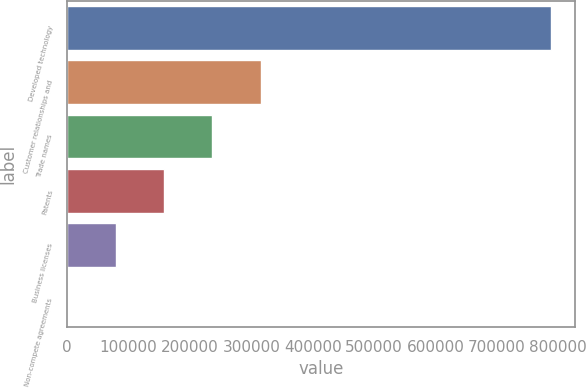Convert chart. <chart><loc_0><loc_0><loc_500><loc_500><bar_chart><fcel>Developed technology<fcel>Customer relationships and<fcel>Trade names<fcel>Patents<fcel>Business licenses<fcel>Non-compete agreements<nl><fcel>788274<fcel>315443<fcel>236638<fcel>157833<fcel>79028.1<fcel>223<nl></chart> 